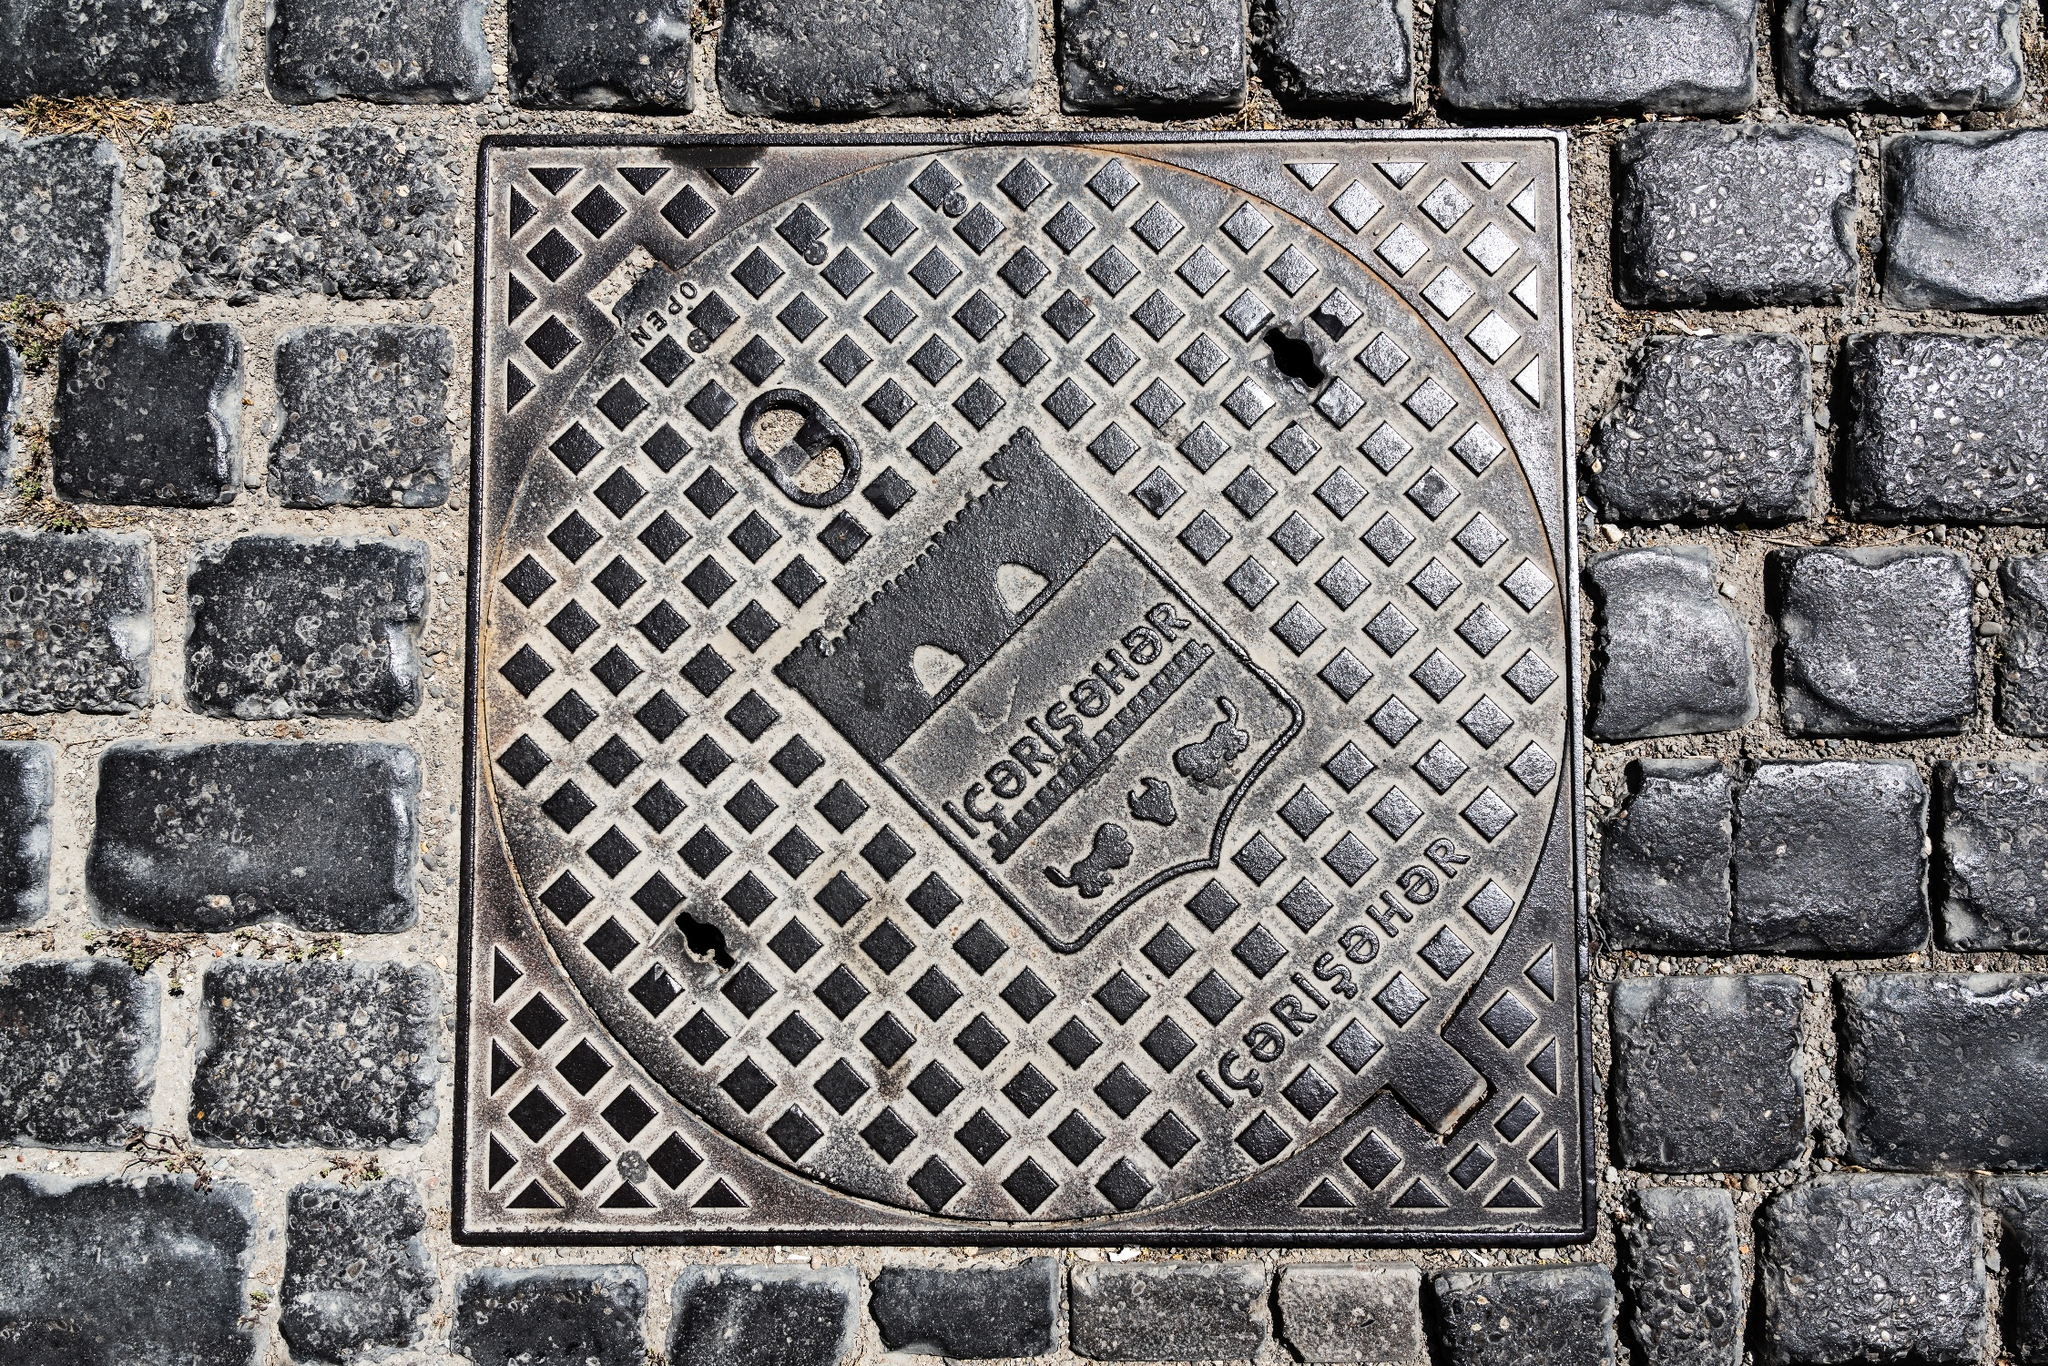What could be the historical context of this manhole cover based on its design and material? The manhole cover, crafted from sturdy metal and adorned with geometric motifs, can be suggestive of an era when functional city elements were made with an eye for detail and durability. The geometric pattern might be characteristic of the decorative trends of the time it was made, while the choice of metal indicates an industrial manufacturing process. It would not be uncommon for such objects to emerge during the 20th century when infrastructure development saw both a functional and aesthetic emphasis in urban planning. 